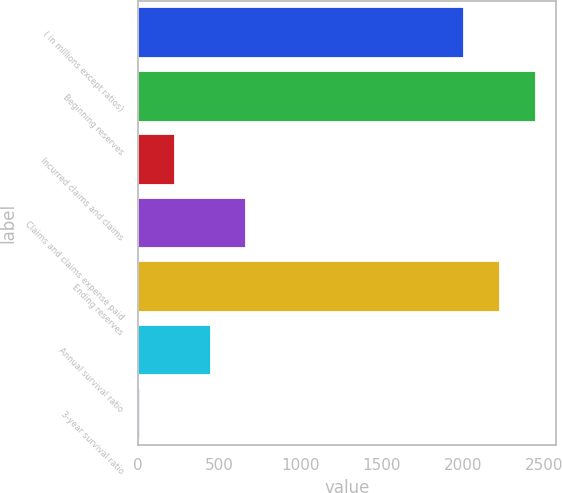Convert chart to OTSL. <chart><loc_0><loc_0><loc_500><loc_500><bar_chart><fcel>( in millions except ratios)<fcel>Beginning reserves<fcel>Incurred claims and claims<fcel>Claims and claims expense paid<fcel>Ending reserves<fcel>Annual survival ratio<fcel>3-year survival ratio<nl><fcel>2007<fcel>2444.9<fcel>227.45<fcel>665.35<fcel>2225.95<fcel>446.4<fcel>8.5<nl></chart> 